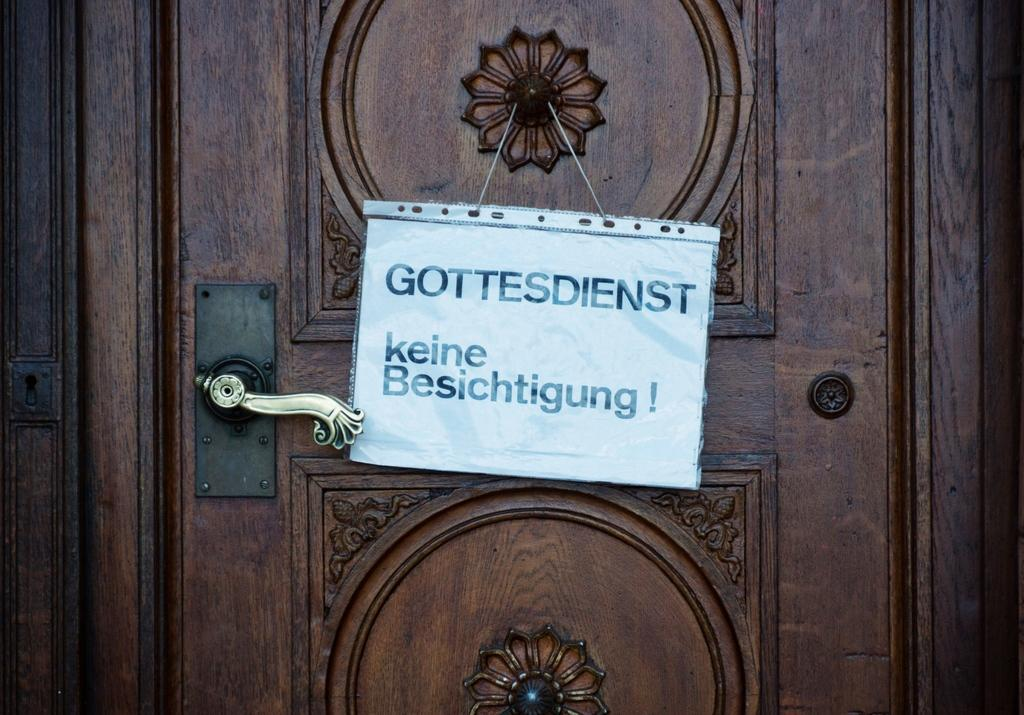What is the main subject of the image? The main subject of the image is a wooden door. Is there anything attached to the door in the image? Yes, there is a text paper hanged on the door. What type of veil can be seen covering the door in the image? There is no veil present in the image; it is a wooden door with a text paper hanged on it. How much sugar is visible on the door in the image? There is no sugar present on the door in the image. 